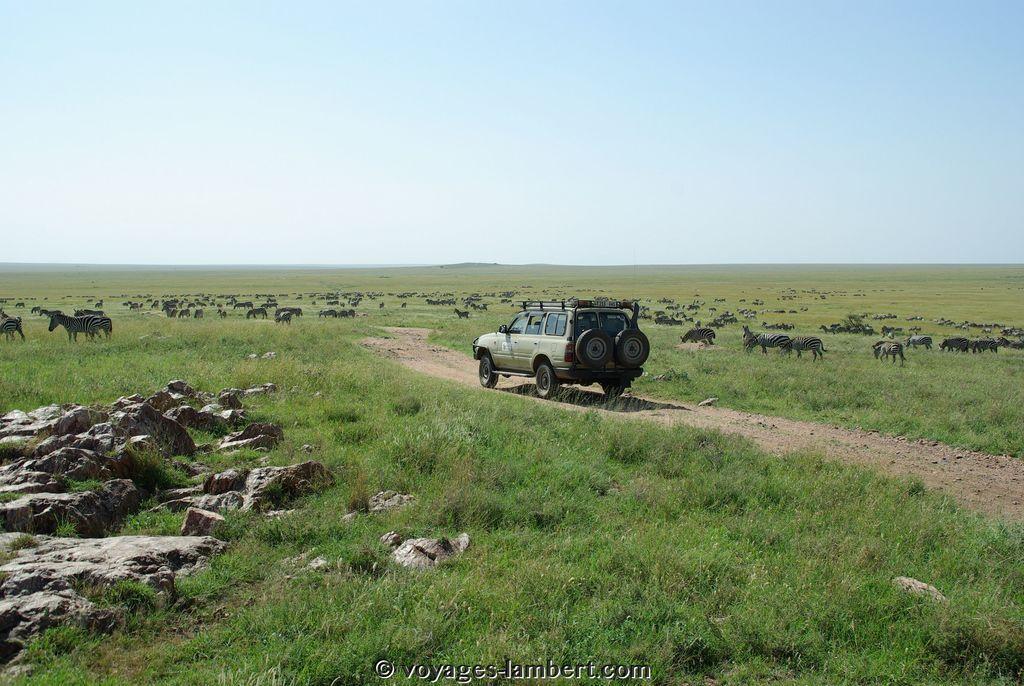Can you describe this image briefly? At the bottom of the image we can see some grass and stones. In the middle of the image we can see a vehicle. Behind the vehicle we can see some animals. At the top of the image we can see the sky. 